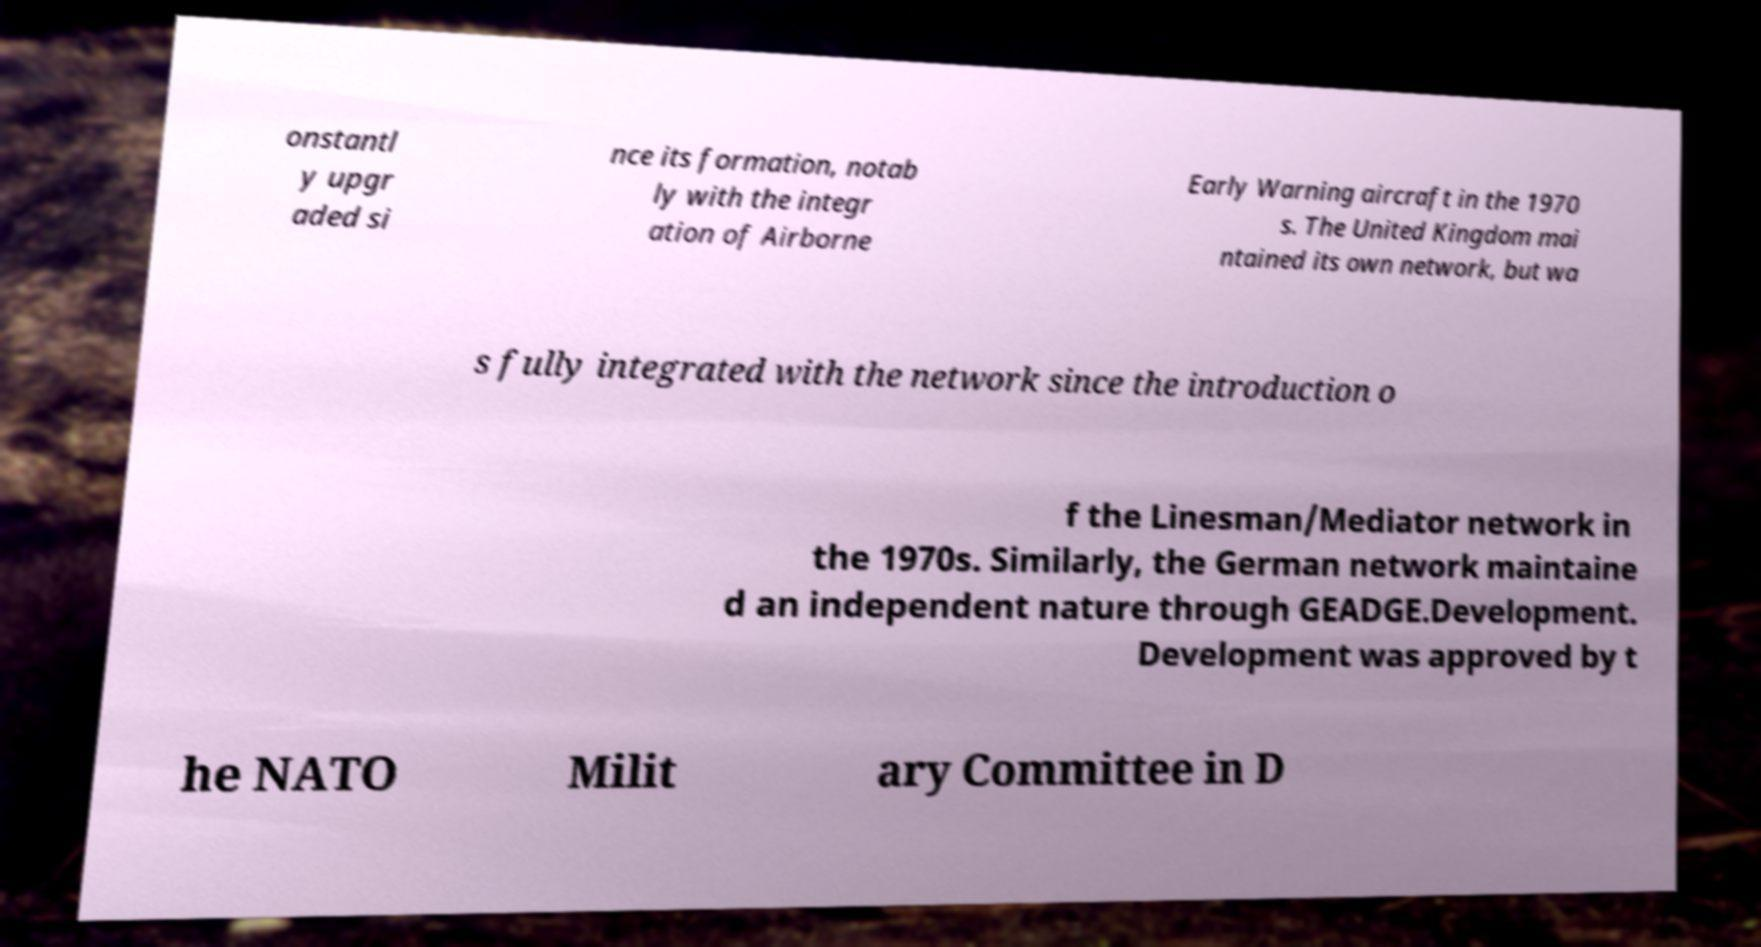Could you assist in decoding the text presented in this image and type it out clearly? onstantl y upgr aded si nce its formation, notab ly with the integr ation of Airborne Early Warning aircraft in the 1970 s. The United Kingdom mai ntained its own network, but wa s fully integrated with the network since the introduction o f the Linesman/Mediator network in the 1970s. Similarly, the German network maintaine d an independent nature through GEADGE.Development. Development was approved by t he NATO Milit ary Committee in D 